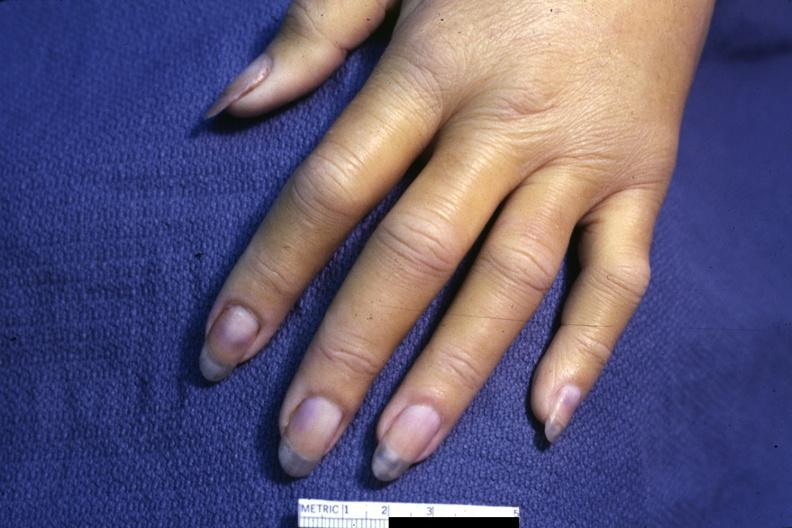what does this image show?
Answer the question using a single word or phrase. Case of dic not bad photo requires dark room to see subtle distal phalangeal cyanosis 